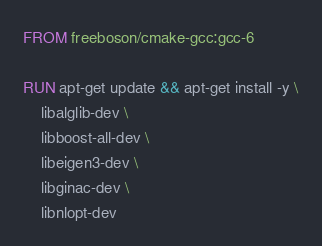<code> <loc_0><loc_0><loc_500><loc_500><_Dockerfile_>FROM freeboson/cmake-gcc:gcc-6

RUN apt-get update && apt-get install -y \
    libalglib-dev \
    libboost-all-dev \
    libeigen3-dev \
    libginac-dev \
    libnlopt-dev

</code> 